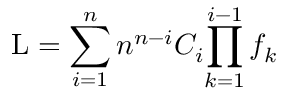<formula> <loc_0><loc_0><loc_500><loc_500>L = \sum _ { i = 1 } ^ { n } n ^ { n - i } C _ { i } { \prod _ { k = 1 } ^ { i - 1 } f _ { k } }</formula> 